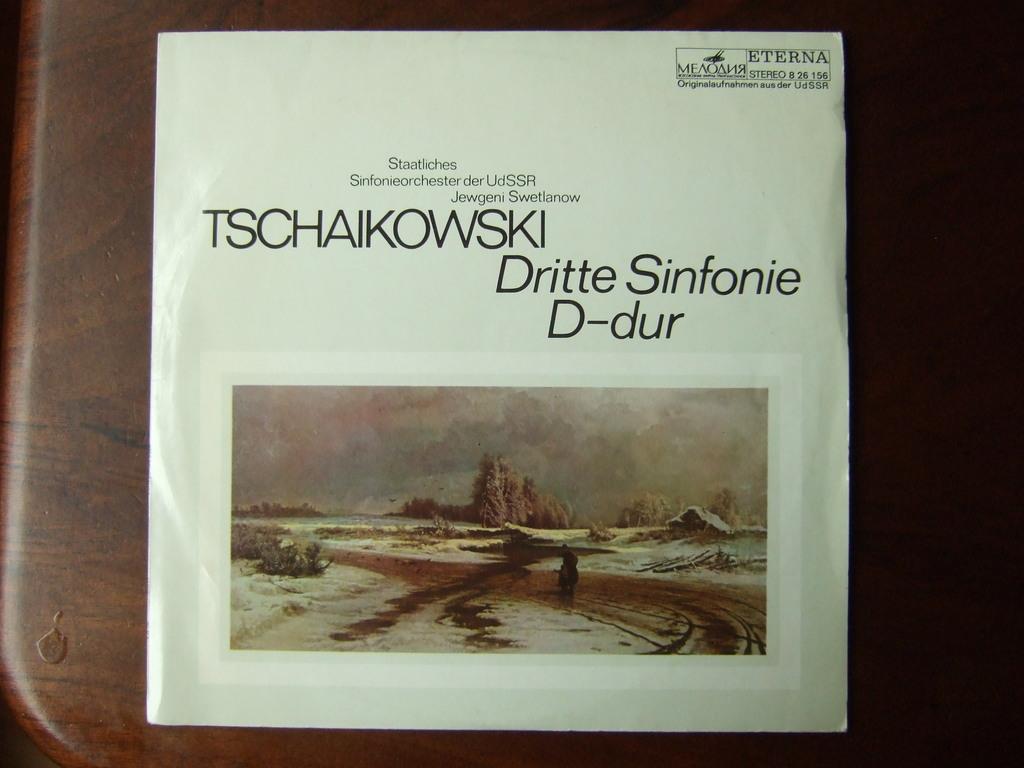Who produced this album seen on the top right corner?
Ensure brevity in your answer.  Eterna. 